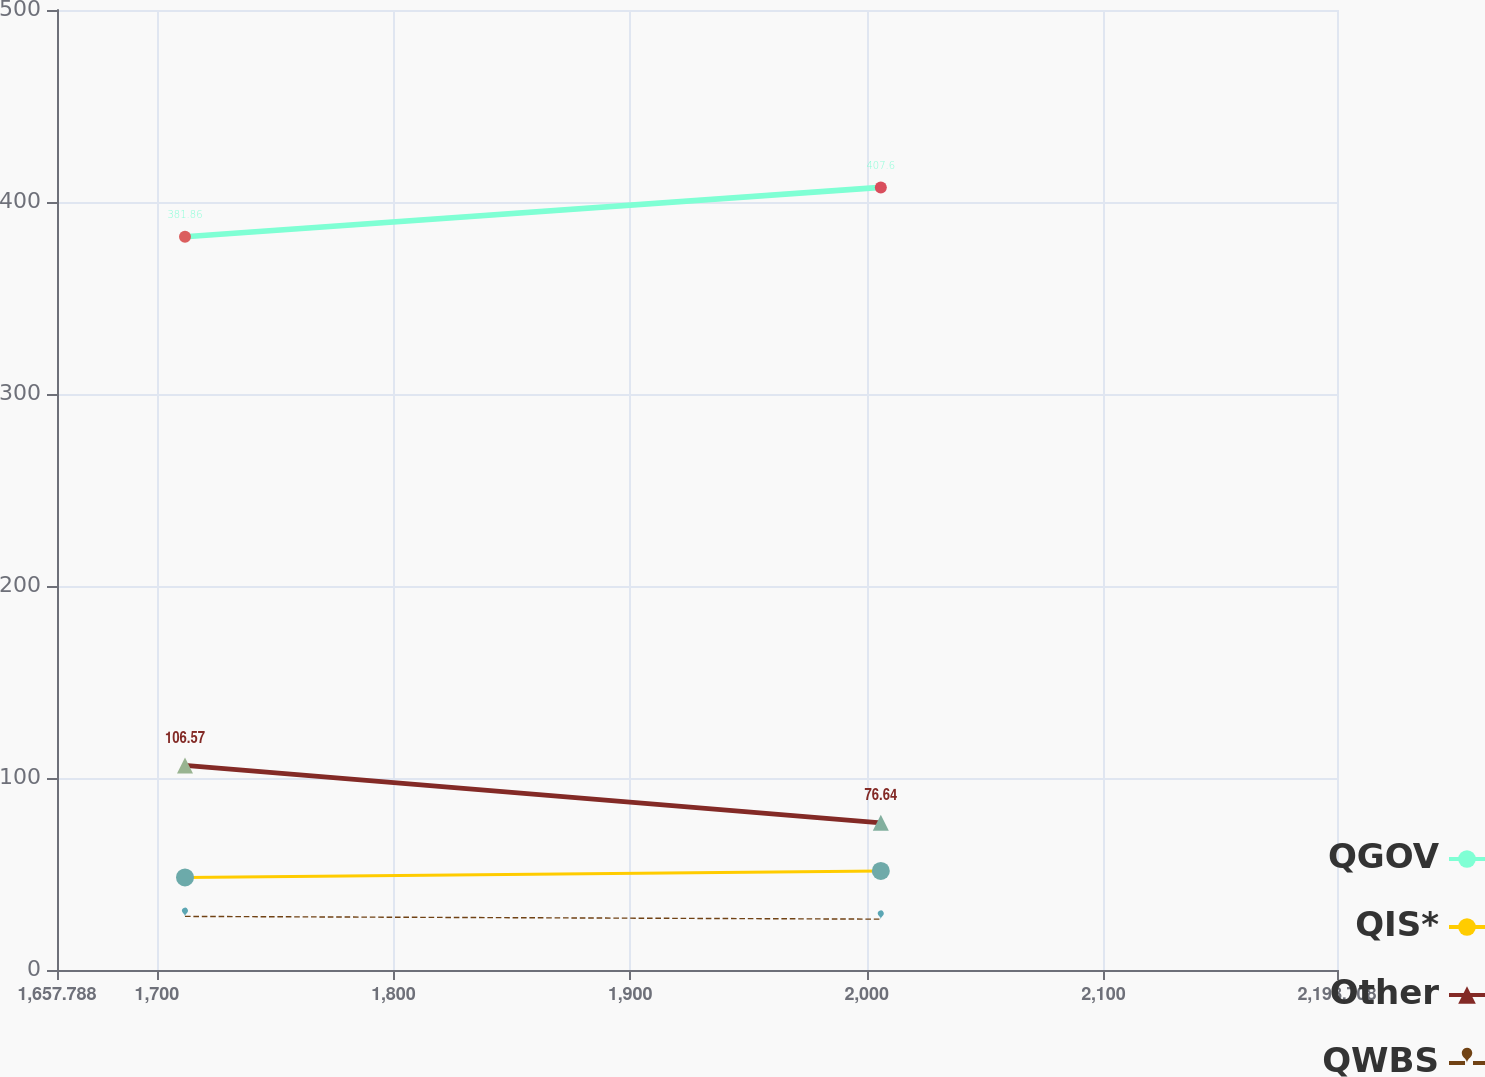Convert chart. <chart><loc_0><loc_0><loc_500><loc_500><line_chart><ecel><fcel>QGOV<fcel>QIS*<fcel>Other<fcel>QWBS<nl><fcel>1711.88<fcel>381.86<fcel>48.19<fcel>106.57<fcel>27.92<nl><fcel>2005.93<fcel>407.6<fcel>51.6<fcel>76.64<fcel>26.48<nl><fcel>2252.8<fcel>331.95<fcel>37.67<fcel>79.83<fcel>12.33<nl></chart> 